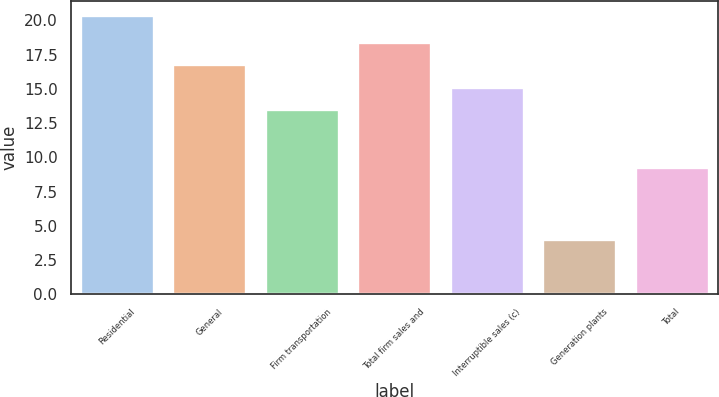Convert chart to OTSL. <chart><loc_0><loc_0><loc_500><loc_500><bar_chart><fcel>Residential<fcel>General<fcel>Firm transportation<fcel>Total firm sales and<fcel>Interruptible sales (c)<fcel>Generation plants<fcel>Total<nl><fcel>20.4<fcel>16.8<fcel>13.5<fcel>18.44<fcel>15.14<fcel>4<fcel>9.3<nl></chart> 